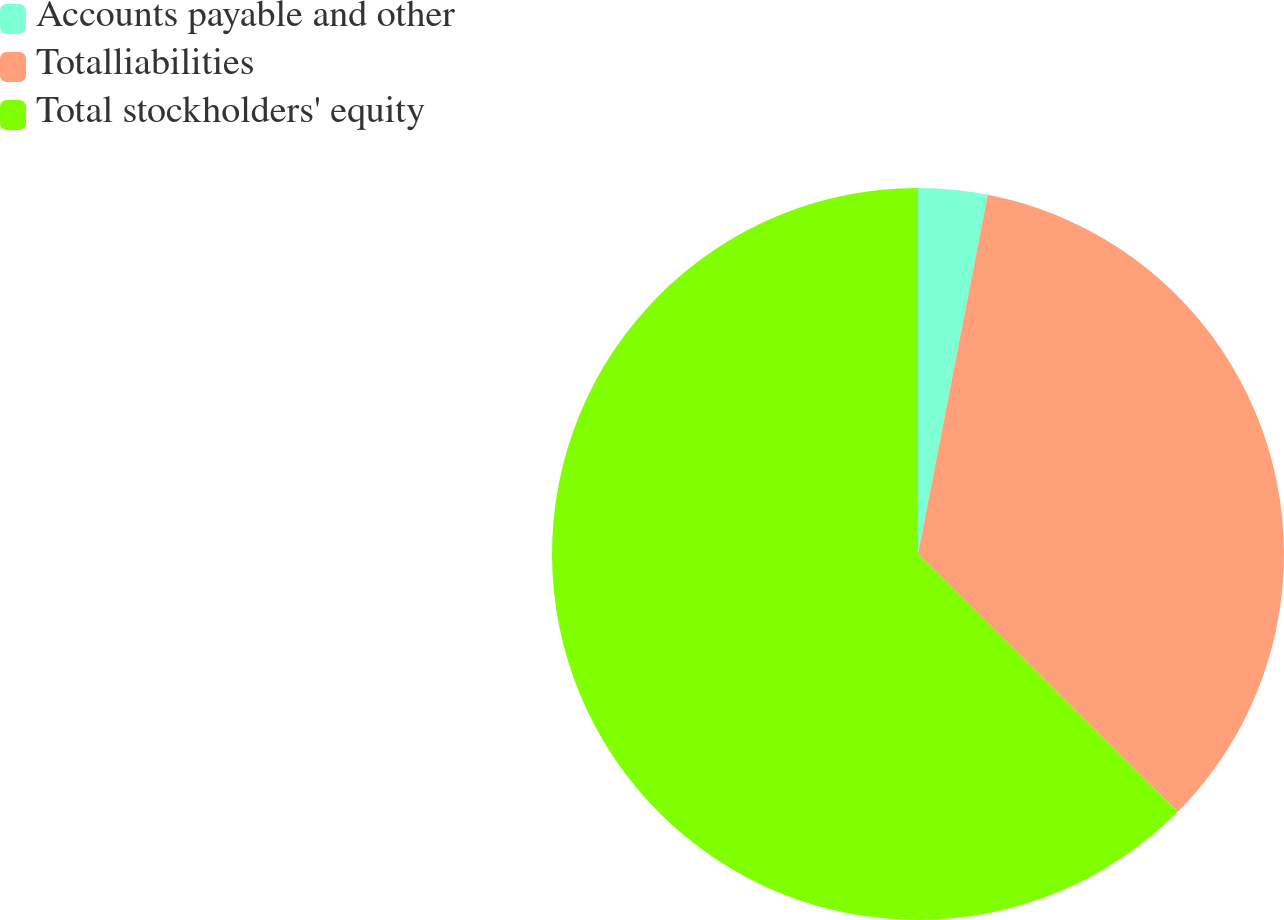Convert chart to OTSL. <chart><loc_0><loc_0><loc_500><loc_500><pie_chart><fcel>Accounts payable and other<fcel>Totalliabilities<fcel>Total stockholders' equity<nl><fcel>3.05%<fcel>34.39%<fcel>62.56%<nl></chart> 